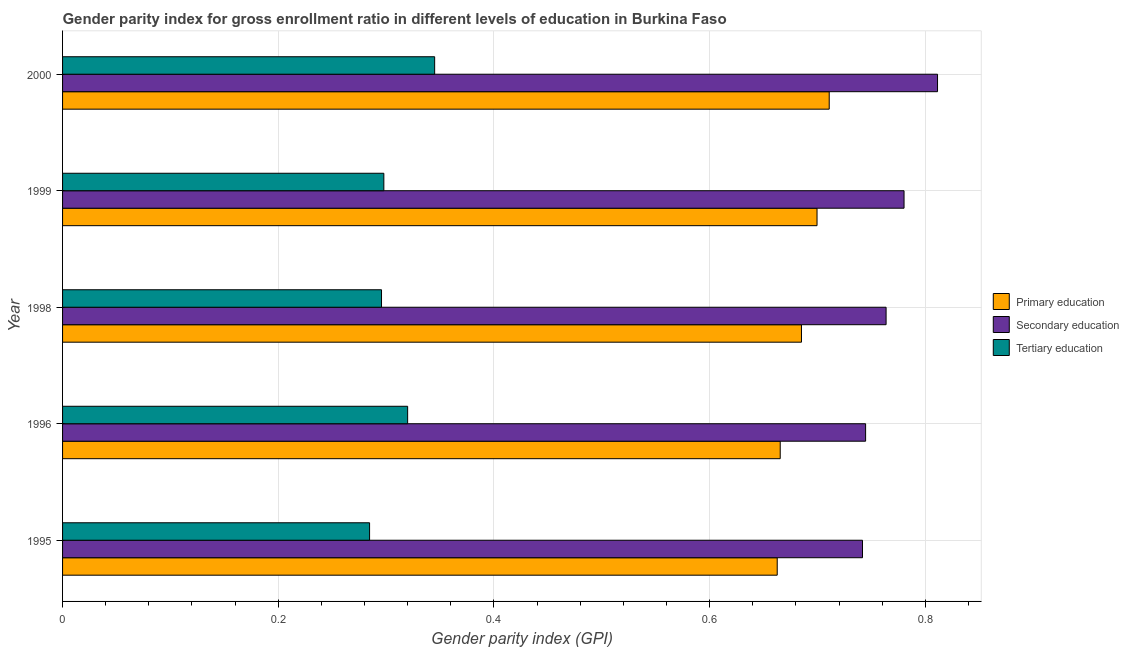How many groups of bars are there?
Keep it short and to the point. 5. Are the number of bars per tick equal to the number of legend labels?
Keep it short and to the point. Yes. How many bars are there on the 2nd tick from the top?
Ensure brevity in your answer.  3. In how many cases, is the number of bars for a given year not equal to the number of legend labels?
Make the answer very short. 0. What is the gender parity index in primary education in 1996?
Offer a very short reply. 0.67. Across all years, what is the maximum gender parity index in secondary education?
Offer a very short reply. 0.81. Across all years, what is the minimum gender parity index in tertiary education?
Your answer should be compact. 0.28. In which year was the gender parity index in secondary education minimum?
Give a very brief answer. 1995. What is the total gender parity index in secondary education in the graph?
Offer a very short reply. 3.84. What is the difference between the gender parity index in secondary education in 1995 and that in 1998?
Offer a very short reply. -0.02. What is the difference between the gender parity index in secondary education in 1995 and the gender parity index in tertiary education in 1998?
Provide a short and direct response. 0.45. What is the average gender parity index in primary education per year?
Keep it short and to the point. 0.69. In the year 1998, what is the difference between the gender parity index in secondary education and gender parity index in tertiary education?
Offer a terse response. 0.47. What is the ratio of the gender parity index in secondary education in 1998 to that in 1999?
Provide a succinct answer. 0.98. Is the gender parity index in primary education in 1995 less than that in 1996?
Give a very brief answer. Yes. Is the difference between the gender parity index in primary education in 1995 and 2000 greater than the difference between the gender parity index in secondary education in 1995 and 2000?
Offer a terse response. Yes. What is the difference between the highest and the second highest gender parity index in secondary education?
Your answer should be very brief. 0.03. In how many years, is the gender parity index in tertiary education greater than the average gender parity index in tertiary education taken over all years?
Give a very brief answer. 2. What does the 1st bar from the top in 1998 represents?
Your answer should be compact. Tertiary education. What does the 2nd bar from the bottom in 1998 represents?
Your response must be concise. Secondary education. Is it the case that in every year, the sum of the gender parity index in primary education and gender parity index in secondary education is greater than the gender parity index in tertiary education?
Ensure brevity in your answer.  Yes. Are all the bars in the graph horizontal?
Give a very brief answer. Yes. How many years are there in the graph?
Offer a terse response. 5. Does the graph contain grids?
Keep it short and to the point. Yes. Where does the legend appear in the graph?
Give a very brief answer. Center right. How many legend labels are there?
Provide a succinct answer. 3. How are the legend labels stacked?
Give a very brief answer. Vertical. What is the title of the graph?
Offer a very short reply. Gender parity index for gross enrollment ratio in different levels of education in Burkina Faso. What is the label or title of the X-axis?
Offer a very short reply. Gender parity index (GPI). What is the Gender parity index (GPI) of Primary education in 1995?
Offer a terse response. 0.66. What is the Gender parity index (GPI) in Secondary education in 1995?
Your answer should be very brief. 0.74. What is the Gender parity index (GPI) in Tertiary education in 1995?
Keep it short and to the point. 0.28. What is the Gender parity index (GPI) in Primary education in 1996?
Give a very brief answer. 0.67. What is the Gender parity index (GPI) of Secondary education in 1996?
Keep it short and to the point. 0.74. What is the Gender parity index (GPI) in Tertiary education in 1996?
Offer a terse response. 0.32. What is the Gender parity index (GPI) of Primary education in 1998?
Provide a succinct answer. 0.69. What is the Gender parity index (GPI) of Secondary education in 1998?
Your answer should be compact. 0.76. What is the Gender parity index (GPI) in Tertiary education in 1998?
Your response must be concise. 0.3. What is the Gender parity index (GPI) in Primary education in 1999?
Provide a short and direct response. 0.7. What is the Gender parity index (GPI) in Secondary education in 1999?
Your answer should be very brief. 0.78. What is the Gender parity index (GPI) of Tertiary education in 1999?
Your response must be concise. 0.3. What is the Gender parity index (GPI) of Primary education in 2000?
Your response must be concise. 0.71. What is the Gender parity index (GPI) in Secondary education in 2000?
Your response must be concise. 0.81. What is the Gender parity index (GPI) in Tertiary education in 2000?
Offer a very short reply. 0.35. Across all years, what is the maximum Gender parity index (GPI) in Primary education?
Your answer should be very brief. 0.71. Across all years, what is the maximum Gender parity index (GPI) in Secondary education?
Provide a short and direct response. 0.81. Across all years, what is the maximum Gender parity index (GPI) of Tertiary education?
Your answer should be compact. 0.35. Across all years, what is the minimum Gender parity index (GPI) in Primary education?
Give a very brief answer. 0.66. Across all years, what is the minimum Gender parity index (GPI) of Secondary education?
Ensure brevity in your answer.  0.74. Across all years, what is the minimum Gender parity index (GPI) of Tertiary education?
Give a very brief answer. 0.28. What is the total Gender parity index (GPI) of Primary education in the graph?
Keep it short and to the point. 3.42. What is the total Gender parity index (GPI) in Secondary education in the graph?
Give a very brief answer. 3.84. What is the total Gender parity index (GPI) in Tertiary education in the graph?
Make the answer very short. 1.54. What is the difference between the Gender parity index (GPI) of Primary education in 1995 and that in 1996?
Your answer should be compact. -0. What is the difference between the Gender parity index (GPI) in Secondary education in 1995 and that in 1996?
Your answer should be very brief. -0. What is the difference between the Gender parity index (GPI) in Tertiary education in 1995 and that in 1996?
Your answer should be very brief. -0.04. What is the difference between the Gender parity index (GPI) in Primary education in 1995 and that in 1998?
Give a very brief answer. -0.02. What is the difference between the Gender parity index (GPI) in Secondary education in 1995 and that in 1998?
Keep it short and to the point. -0.02. What is the difference between the Gender parity index (GPI) in Tertiary education in 1995 and that in 1998?
Your answer should be compact. -0.01. What is the difference between the Gender parity index (GPI) of Primary education in 1995 and that in 1999?
Provide a short and direct response. -0.04. What is the difference between the Gender parity index (GPI) of Secondary education in 1995 and that in 1999?
Your response must be concise. -0.04. What is the difference between the Gender parity index (GPI) of Tertiary education in 1995 and that in 1999?
Give a very brief answer. -0.01. What is the difference between the Gender parity index (GPI) of Primary education in 1995 and that in 2000?
Offer a very short reply. -0.05. What is the difference between the Gender parity index (GPI) of Secondary education in 1995 and that in 2000?
Give a very brief answer. -0.07. What is the difference between the Gender parity index (GPI) of Tertiary education in 1995 and that in 2000?
Offer a very short reply. -0.06. What is the difference between the Gender parity index (GPI) of Primary education in 1996 and that in 1998?
Offer a terse response. -0.02. What is the difference between the Gender parity index (GPI) of Secondary education in 1996 and that in 1998?
Your answer should be compact. -0.02. What is the difference between the Gender parity index (GPI) in Tertiary education in 1996 and that in 1998?
Your answer should be very brief. 0.02. What is the difference between the Gender parity index (GPI) in Primary education in 1996 and that in 1999?
Your response must be concise. -0.03. What is the difference between the Gender parity index (GPI) in Secondary education in 1996 and that in 1999?
Make the answer very short. -0.04. What is the difference between the Gender parity index (GPI) in Tertiary education in 1996 and that in 1999?
Provide a succinct answer. 0.02. What is the difference between the Gender parity index (GPI) of Primary education in 1996 and that in 2000?
Your answer should be very brief. -0.05. What is the difference between the Gender parity index (GPI) of Secondary education in 1996 and that in 2000?
Your answer should be very brief. -0.07. What is the difference between the Gender parity index (GPI) in Tertiary education in 1996 and that in 2000?
Your answer should be compact. -0.03. What is the difference between the Gender parity index (GPI) of Primary education in 1998 and that in 1999?
Your response must be concise. -0.01. What is the difference between the Gender parity index (GPI) of Secondary education in 1998 and that in 1999?
Your response must be concise. -0.02. What is the difference between the Gender parity index (GPI) of Tertiary education in 1998 and that in 1999?
Ensure brevity in your answer.  -0. What is the difference between the Gender parity index (GPI) of Primary education in 1998 and that in 2000?
Keep it short and to the point. -0.03. What is the difference between the Gender parity index (GPI) in Secondary education in 1998 and that in 2000?
Ensure brevity in your answer.  -0.05. What is the difference between the Gender parity index (GPI) in Tertiary education in 1998 and that in 2000?
Give a very brief answer. -0.05. What is the difference between the Gender parity index (GPI) of Primary education in 1999 and that in 2000?
Your response must be concise. -0.01. What is the difference between the Gender parity index (GPI) in Secondary education in 1999 and that in 2000?
Your answer should be very brief. -0.03. What is the difference between the Gender parity index (GPI) of Tertiary education in 1999 and that in 2000?
Your answer should be compact. -0.05. What is the difference between the Gender parity index (GPI) in Primary education in 1995 and the Gender parity index (GPI) in Secondary education in 1996?
Ensure brevity in your answer.  -0.08. What is the difference between the Gender parity index (GPI) in Primary education in 1995 and the Gender parity index (GPI) in Tertiary education in 1996?
Provide a succinct answer. 0.34. What is the difference between the Gender parity index (GPI) of Secondary education in 1995 and the Gender parity index (GPI) of Tertiary education in 1996?
Make the answer very short. 0.42. What is the difference between the Gender parity index (GPI) in Primary education in 1995 and the Gender parity index (GPI) in Secondary education in 1998?
Give a very brief answer. -0.1. What is the difference between the Gender parity index (GPI) in Primary education in 1995 and the Gender parity index (GPI) in Tertiary education in 1998?
Ensure brevity in your answer.  0.37. What is the difference between the Gender parity index (GPI) in Secondary education in 1995 and the Gender parity index (GPI) in Tertiary education in 1998?
Your response must be concise. 0.45. What is the difference between the Gender parity index (GPI) of Primary education in 1995 and the Gender parity index (GPI) of Secondary education in 1999?
Your answer should be very brief. -0.12. What is the difference between the Gender parity index (GPI) in Primary education in 1995 and the Gender parity index (GPI) in Tertiary education in 1999?
Ensure brevity in your answer.  0.36. What is the difference between the Gender parity index (GPI) in Secondary education in 1995 and the Gender parity index (GPI) in Tertiary education in 1999?
Your answer should be very brief. 0.44. What is the difference between the Gender parity index (GPI) of Primary education in 1995 and the Gender parity index (GPI) of Secondary education in 2000?
Offer a terse response. -0.15. What is the difference between the Gender parity index (GPI) of Primary education in 1995 and the Gender parity index (GPI) of Tertiary education in 2000?
Your response must be concise. 0.32. What is the difference between the Gender parity index (GPI) of Secondary education in 1995 and the Gender parity index (GPI) of Tertiary education in 2000?
Provide a succinct answer. 0.4. What is the difference between the Gender parity index (GPI) in Primary education in 1996 and the Gender parity index (GPI) in Secondary education in 1998?
Provide a succinct answer. -0.1. What is the difference between the Gender parity index (GPI) of Primary education in 1996 and the Gender parity index (GPI) of Tertiary education in 1998?
Offer a terse response. 0.37. What is the difference between the Gender parity index (GPI) of Secondary education in 1996 and the Gender parity index (GPI) of Tertiary education in 1998?
Your response must be concise. 0.45. What is the difference between the Gender parity index (GPI) in Primary education in 1996 and the Gender parity index (GPI) in Secondary education in 1999?
Provide a succinct answer. -0.11. What is the difference between the Gender parity index (GPI) of Primary education in 1996 and the Gender parity index (GPI) of Tertiary education in 1999?
Offer a very short reply. 0.37. What is the difference between the Gender parity index (GPI) of Secondary education in 1996 and the Gender parity index (GPI) of Tertiary education in 1999?
Your response must be concise. 0.45. What is the difference between the Gender parity index (GPI) of Primary education in 1996 and the Gender parity index (GPI) of Secondary education in 2000?
Make the answer very short. -0.15. What is the difference between the Gender parity index (GPI) in Primary education in 1996 and the Gender parity index (GPI) in Tertiary education in 2000?
Your answer should be very brief. 0.32. What is the difference between the Gender parity index (GPI) in Secondary education in 1996 and the Gender parity index (GPI) in Tertiary education in 2000?
Ensure brevity in your answer.  0.4. What is the difference between the Gender parity index (GPI) of Primary education in 1998 and the Gender parity index (GPI) of Secondary education in 1999?
Provide a short and direct response. -0.1. What is the difference between the Gender parity index (GPI) of Primary education in 1998 and the Gender parity index (GPI) of Tertiary education in 1999?
Offer a terse response. 0.39. What is the difference between the Gender parity index (GPI) in Secondary education in 1998 and the Gender parity index (GPI) in Tertiary education in 1999?
Keep it short and to the point. 0.47. What is the difference between the Gender parity index (GPI) of Primary education in 1998 and the Gender parity index (GPI) of Secondary education in 2000?
Your response must be concise. -0.13. What is the difference between the Gender parity index (GPI) of Primary education in 1998 and the Gender parity index (GPI) of Tertiary education in 2000?
Provide a succinct answer. 0.34. What is the difference between the Gender parity index (GPI) of Secondary education in 1998 and the Gender parity index (GPI) of Tertiary education in 2000?
Provide a short and direct response. 0.42. What is the difference between the Gender parity index (GPI) of Primary education in 1999 and the Gender parity index (GPI) of Secondary education in 2000?
Your response must be concise. -0.11. What is the difference between the Gender parity index (GPI) of Primary education in 1999 and the Gender parity index (GPI) of Tertiary education in 2000?
Your answer should be compact. 0.35. What is the difference between the Gender parity index (GPI) in Secondary education in 1999 and the Gender parity index (GPI) in Tertiary education in 2000?
Your answer should be compact. 0.44. What is the average Gender parity index (GPI) in Primary education per year?
Make the answer very short. 0.68. What is the average Gender parity index (GPI) in Secondary education per year?
Keep it short and to the point. 0.77. What is the average Gender parity index (GPI) in Tertiary education per year?
Make the answer very short. 0.31. In the year 1995, what is the difference between the Gender parity index (GPI) in Primary education and Gender parity index (GPI) in Secondary education?
Your answer should be very brief. -0.08. In the year 1995, what is the difference between the Gender parity index (GPI) of Primary education and Gender parity index (GPI) of Tertiary education?
Make the answer very short. 0.38. In the year 1995, what is the difference between the Gender parity index (GPI) of Secondary education and Gender parity index (GPI) of Tertiary education?
Give a very brief answer. 0.46. In the year 1996, what is the difference between the Gender parity index (GPI) in Primary education and Gender parity index (GPI) in Secondary education?
Your answer should be compact. -0.08. In the year 1996, what is the difference between the Gender parity index (GPI) in Primary education and Gender parity index (GPI) in Tertiary education?
Make the answer very short. 0.35. In the year 1996, what is the difference between the Gender parity index (GPI) in Secondary education and Gender parity index (GPI) in Tertiary education?
Your response must be concise. 0.42. In the year 1998, what is the difference between the Gender parity index (GPI) in Primary education and Gender parity index (GPI) in Secondary education?
Your answer should be compact. -0.08. In the year 1998, what is the difference between the Gender parity index (GPI) of Primary education and Gender parity index (GPI) of Tertiary education?
Your response must be concise. 0.39. In the year 1998, what is the difference between the Gender parity index (GPI) of Secondary education and Gender parity index (GPI) of Tertiary education?
Make the answer very short. 0.47. In the year 1999, what is the difference between the Gender parity index (GPI) of Primary education and Gender parity index (GPI) of Secondary education?
Make the answer very short. -0.08. In the year 1999, what is the difference between the Gender parity index (GPI) of Primary education and Gender parity index (GPI) of Tertiary education?
Provide a short and direct response. 0.4. In the year 1999, what is the difference between the Gender parity index (GPI) in Secondary education and Gender parity index (GPI) in Tertiary education?
Your answer should be very brief. 0.48. In the year 2000, what is the difference between the Gender parity index (GPI) in Primary education and Gender parity index (GPI) in Secondary education?
Ensure brevity in your answer.  -0.1. In the year 2000, what is the difference between the Gender parity index (GPI) of Primary education and Gender parity index (GPI) of Tertiary education?
Provide a succinct answer. 0.37. In the year 2000, what is the difference between the Gender parity index (GPI) of Secondary education and Gender parity index (GPI) of Tertiary education?
Offer a very short reply. 0.47. What is the ratio of the Gender parity index (GPI) in Primary education in 1995 to that in 1996?
Offer a very short reply. 1. What is the ratio of the Gender parity index (GPI) in Secondary education in 1995 to that in 1996?
Provide a succinct answer. 1. What is the ratio of the Gender parity index (GPI) of Tertiary education in 1995 to that in 1996?
Offer a very short reply. 0.89. What is the ratio of the Gender parity index (GPI) of Primary education in 1995 to that in 1998?
Your response must be concise. 0.97. What is the ratio of the Gender parity index (GPI) in Secondary education in 1995 to that in 1998?
Provide a succinct answer. 0.97. What is the ratio of the Gender parity index (GPI) in Tertiary education in 1995 to that in 1998?
Provide a succinct answer. 0.96. What is the ratio of the Gender parity index (GPI) of Primary education in 1995 to that in 1999?
Give a very brief answer. 0.95. What is the ratio of the Gender parity index (GPI) of Secondary education in 1995 to that in 1999?
Your response must be concise. 0.95. What is the ratio of the Gender parity index (GPI) of Tertiary education in 1995 to that in 1999?
Offer a very short reply. 0.96. What is the ratio of the Gender parity index (GPI) of Primary education in 1995 to that in 2000?
Provide a succinct answer. 0.93. What is the ratio of the Gender parity index (GPI) in Secondary education in 1995 to that in 2000?
Give a very brief answer. 0.91. What is the ratio of the Gender parity index (GPI) of Tertiary education in 1995 to that in 2000?
Your answer should be very brief. 0.83. What is the ratio of the Gender parity index (GPI) in Primary education in 1996 to that in 1998?
Provide a short and direct response. 0.97. What is the ratio of the Gender parity index (GPI) of Secondary education in 1996 to that in 1998?
Make the answer very short. 0.98. What is the ratio of the Gender parity index (GPI) of Tertiary education in 1996 to that in 1998?
Keep it short and to the point. 1.08. What is the ratio of the Gender parity index (GPI) of Primary education in 1996 to that in 1999?
Ensure brevity in your answer.  0.95. What is the ratio of the Gender parity index (GPI) in Secondary education in 1996 to that in 1999?
Provide a succinct answer. 0.95. What is the ratio of the Gender parity index (GPI) in Tertiary education in 1996 to that in 1999?
Offer a terse response. 1.07. What is the ratio of the Gender parity index (GPI) of Primary education in 1996 to that in 2000?
Offer a terse response. 0.94. What is the ratio of the Gender parity index (GPI) in Secondary education in 1996 to that in 2000?
Make the answer very short. 0.92. What is the ratio of the Gender parity index (GPI) in Tertiary education in 1996 to that in 2000?
Your answer should be compact. 0.93. What is the ratio of the Gender parity index (GPI) of Primary education in 1998 to that in 1999?
Ensure brevity in your answer.  0.98. What is the ratio of the Gender parity index (GPI) of Secondary education in 1998 to that in 1999?
Provide a succinct answer. 0.98. What is the ratio of the Gender parity index (GPI) of Tertiary education in 1998 to that in 1999?
Provide a short and direct response. 0.99. What is the ratio of the Gender parity index (GPI) of Primary education in 1998 to that in 2000?
Provide a succinct answer. 0.96. What is the ratio of the Gender parity index (GPI) of Tertiary education in 1998 to that in 2000?
Provide a succinct answer. 0.86. What is the ratio of the Gender parity index (GPI) in Primary education in 1999 to that in 2000?
Provide a succinct answer. 0.98. What is the ratio of the Gender parity index (GPI) of Secondary education in 1999 to that in 2000?
Keep it short and to the point. 0.96. What is the ratio of the Gender parity index (GPI) in Tertiary education in 1999 to that in 2000?
Keep it short and to the point. 0.86. What is the difference between the highest and the second highest Gender parity index (GPI) of Primary education?
Keep it short and to the point. 0.01. What is the difference between the highest and the second highest Gender parity index (GPI) of Secondary education?
Your answer should be compact. 0.03. What is the difference between the highest and the second highest Gender parity index (GPI) of Tertiary education?
Keep it short and to the point. 0.03. What is the difference between the highest and the lowest Gender parity index (GPI) in Primary education?
Your answer should be very brief. 0.05. What is the difference between the highest and the lowest Gender parity index (GPI) of Secondary education?
Offer a terse response. 0.07. What is the difference between the highest and the lowest Gender parity index (GPI) of Tertiary education?
Ensure brevity in your answer.  0.06. 